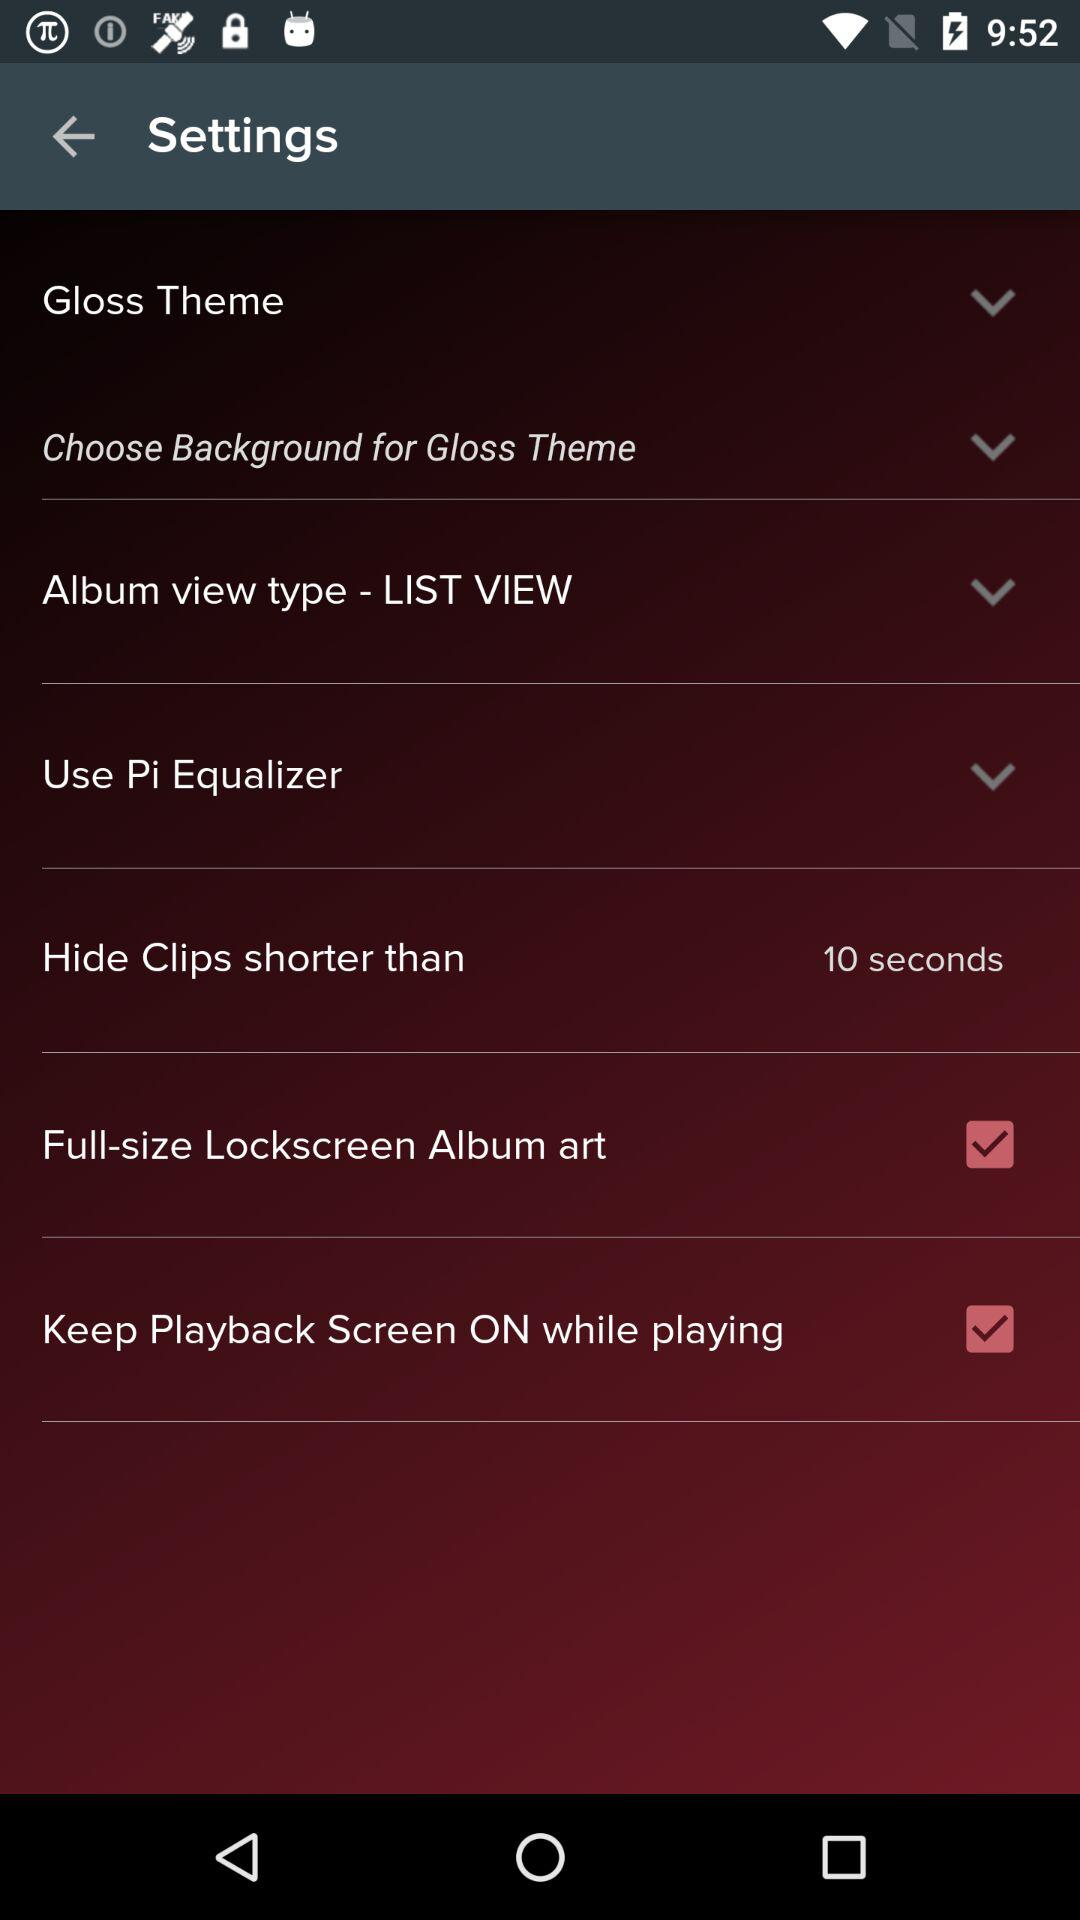What is the view type of the album? The view type of the album is "LIST VIEW". 